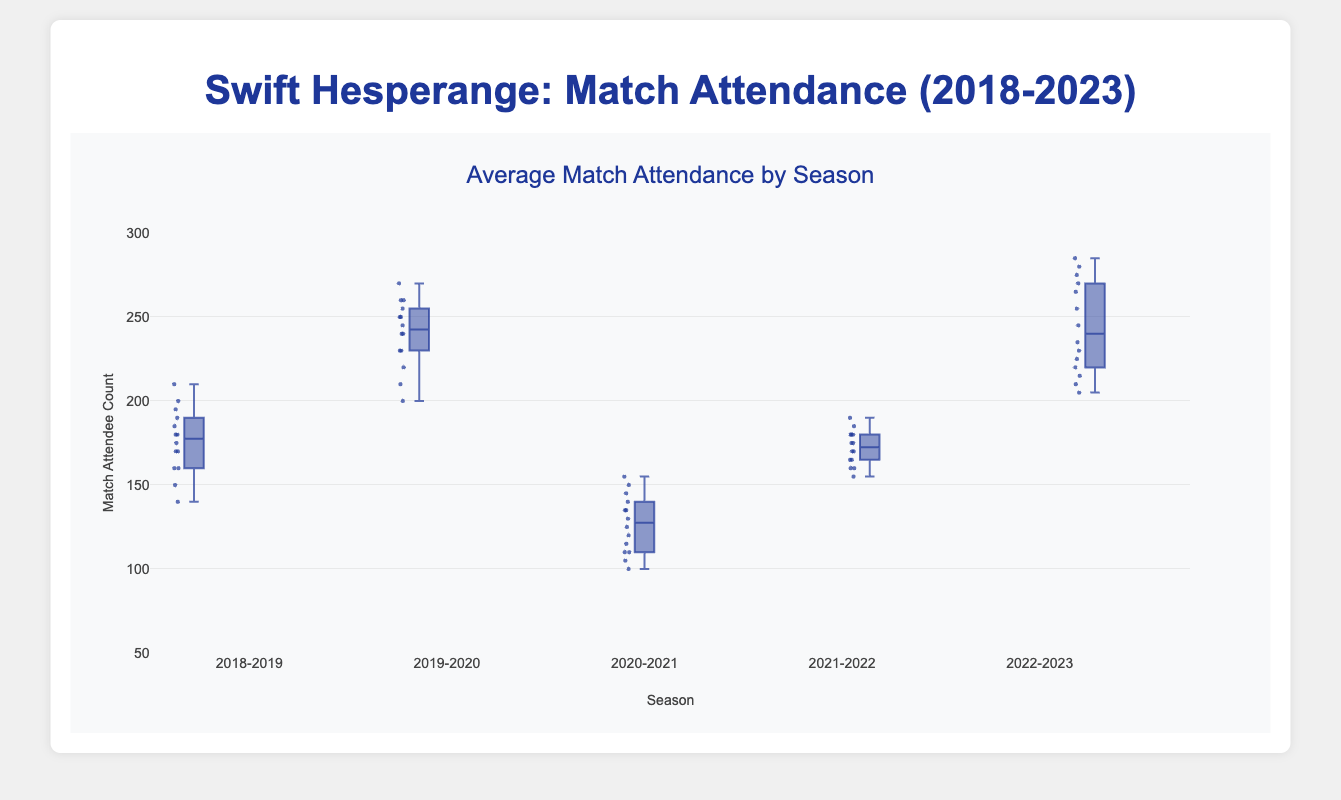What is the range of attendance for the 2020-2021 season? The range is determined by the difference between the highest and lowest attendee count in the 2020-2021 season. The highest value is 155 and the lowest value is 100, so the range is 155 - 100 = 55
Answer: 55 Which season had the highest median match attendance? By examining the median line within each box, the season with the highest median match attendance is 2022-2023
Answer: 2022-2023 How does the average match attendance of the 2020-2021 season compare to the median attendance of the same season? First, calculate the average: (100 + 120 + 110 + 130 + 150 + 140 + 135 + 155 + 145 + 135 + 125 + 110 + 115 + 105) / 14 ≈ 124.29. The median can be seen from the box plot and it appears to be around 130. The average (≈124.29) is slightly less than the median (130)
Answer: The average is slightly less than the median What is the interquartile range (IQR) for the 2021-2022 season? The IQR is the difference between the third quartile (Q3) and the first quartile (Q1). From the box plot, identify Q3 which is around 180 and Q1 which is around 165. So, IQR = 180 - 165 = 15
Answer: 15 Which season had the most consistent match attendance? Consistency can be identified by the size of the box, with a smaller box indicating more consistency. The 2021-2022 season has the smallest box, indicating the most consistent match attendance
Answer: 2021-2022 Between the 2019-2020 and 2022-2023 seasons, which one had a greater variation in match attendance? Variation can be measured by the range or the interquartile range (IQR). The 2019-2020 season has a more spread-out box compared to the 2022-2023 season, indicating greater variation.
Answer: 2019-2020 What is the median match attendee count for the 2018-2019 season? The median is the middle value indicated by the line within the box. For the 2018-2019 season, this line is around 175
Answer: 175 